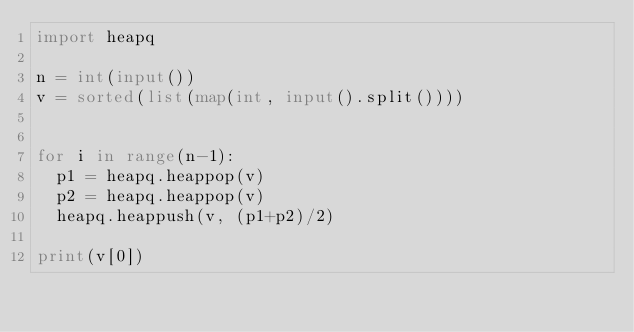<code> <loc_0><loc_0><loc_500><loc_500><_Python_>import heapq

n = int(input())
v = sorted(list(map(int, input().split())))


for i in range(n-1):
  p1 = heapq.heappop(v)
  p2 = heapq.heappop(v)
  heapq.heappush(v, (p1+p2)/2)

print(v[0])</code> 